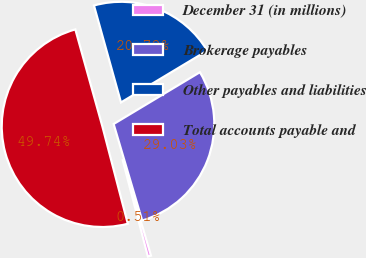<chart> <loc_0><loc_0><loc_500><loc_500><pie_chart><fcel>December 31 (in millions)<fcel>Brokerage payables<fcel>Other payables and liabilities<fcel>Total accounts payable and<nl><fcel>0.51%<fcel>29.03%<fcel>20.72%<fcel>49.74%<nl></chart> 